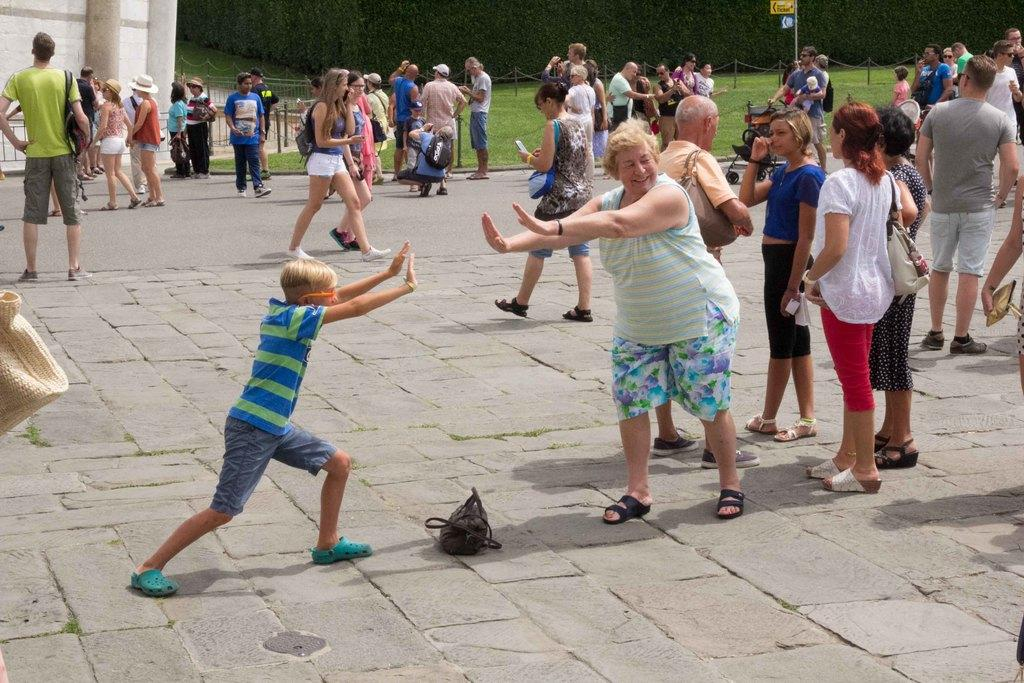What is happening on the road in the image? There are many persons on the road in the image. What object can be seen at the bottom of the image? There is a bag at the bottom of the image. What can be seen in the background of the image? There are many trees in the background of the image. What is located on the left side of the image? There is a building with fencing on the left side of the image. What type of beetle can be seen crawling on the building in the image? There is no beetle present in the image; it only features persons on the road, a bag, trees, and a building with fencing. What punishment is being given to the persons on the road in the image? There is no indication of punishment in the image; the persons on the road are simply present. 